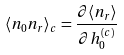Convert formula to latex. <formula><loc_0><loc_0><loc_500><loc_500>\langle n _ { 0 } n _ { r } \rangle _ { c } = \frac { \partial \langle n _ { r } \rangle } { \partial h _ { 0 } ^ { ( c ) } }</formula> 